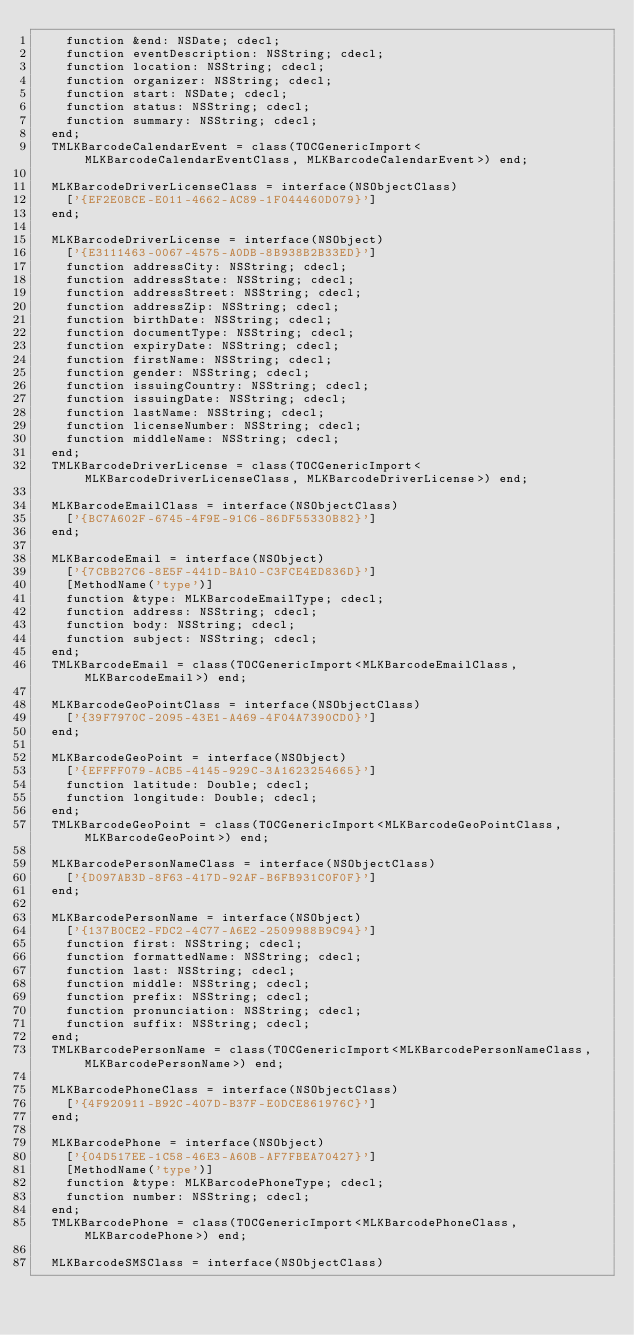<code> <loc_0><loc_0><loc_500><loc_500><_Pascal_>    function &end: NSDate; cdecl;
    function eventDescription: NSString; cdecl;
    function location: NSString; cdecl;
    function organizer: NSString; cdecl;
    function start: NSDate; cdecl;
    function status: NSString; cdecl;
    function summary: NSString; cdecl;
  end;
  TMLKBarcodeCalendarEvent = class(TOCGenericImport<MLKBarcodeCalendarEventClass, MLKBarcodeCalendarEvent>) end;

  MLKBarcodeDriverLicenseClass = interface(NSObjectClass)
    ['{EF2E0BCE-E011-4662-AC89-1F044460D079}']
  end;

  MLKBarcodeDriverLicense = interface(NSObject)
    ['{E3111463-0067-4575-A0DB-8B938B2B33ED}']
    function addressCity: NSString; cdecl;
    function addressState: NSString; cdecl;
    function addressStreet: NSString; cdecl;
    function addressZip: NSString; cdecl;
    function birthDate: NSString; cdecl;
    function documentType: NSString; cdecl;
    function expiryDate: NSString; cdecl;
    function firstName: NSString; cdecl;
    function gender: NSString; cdecl;
    function issuingCountry: NSString; cdecl;
    function issuingDate: NSString; cdecl;
    function lastName: NSString; cdecl;
    function licenseNumber: NSString; cdecl;
    function middleName: NSString; cdecl;
  end;
  TMLKBarcodeDriverLicense = class(TOCGenericImport<MLKBarcodeDriverLicenseClass, MLKBarcodeDriverLicense>) end;

  MLKBarcodeEmailClass = interface(NSObjectClass)
    ['{BC7A602F-6745-4F9E-91C6-86DF55330B82}']
  end;

  MLKBarcodeEmail = interface(NSObject)
    ['{7CBB27C6-8E5F-441D-BA10-C3FCE4ED836D}']
    [MethodName('type')]
    function &type: MLKBarcodeEmailType; cdecl;
    function address: NSString; cdecl;
    function body: NSString; cdecl;
    function subject: NSString; cdecl;
  end;
  TMLKBarcodeEmail = class(TOCGenericImport<MLKBarcodeEmailClass, MLKBarcodeEmail>) end;

  MLKBarcodeGeoPointClass = interface(NSObjectClass)
    ['{39F7970C-2095-43E1-A469-4F04A7390CD0}']
  end;

  MLKBarcodeGeoPoint = interface(NSObject)
    ['{EFFFF079-ACB5-4145-929C-3A1623254665}']
    function latitude: Double; cdecl;
    function longitude: Double; cdecl;
  end;
  TMLKBarcodeGeoPoint = class(TOCGenericImport<MLKBarcodeGeoPointClass, MLKBarcodeGeoPoint>) end;

  MLKBarcodePersonNameClass = interface(NSObjectClass)
    ['{D097AB3D-8F63-417D-92AF-B6FB931C0F0F}']
  end;

  MLKBarcodePersonName = interface(NSObject)
    ['{137B0CE2-FDC2-4C77-A6E2-2509988B9C94}']
    function first: NSString; cdecl;
    function formattedName: NSString; cdecl;
    function last: NSString; cdecl;
    function middle: NSString; cdecl;
    function prefix: NSString; cdecl;
    function pronunciation: NSString; cdecl;
    function suffix: NSString; cdecl;
  end;
  TMLKBarcodePersonName = class(TOCGenericImport<MLKBarcodePersonNameClass, MLKBarcodePersonName>) end;

  MLKBarcodePhoneClass = interface(NSObjectClass)
    ['{4F920911-B92C-407D-B37F-E0DCE861976C}']
  end;

  MLKBarcodePhone = interface(NSObject)
    ['{04D517EE-1C58-46E3-A60B-AF7FBEA70427}']
    [MethodName('type')]
    function &type: MLKBarcodePhoneType; cdecl;
    function number: NSString; cdecl;
  end;
  TMLKBarcodePhone = class(TOCGenericImport<MLKBarcodePhoneClass, MLKBarcodePhone>) end;

  MLKBarcodeSMSClass = interface(NSObjectClass)</code> 